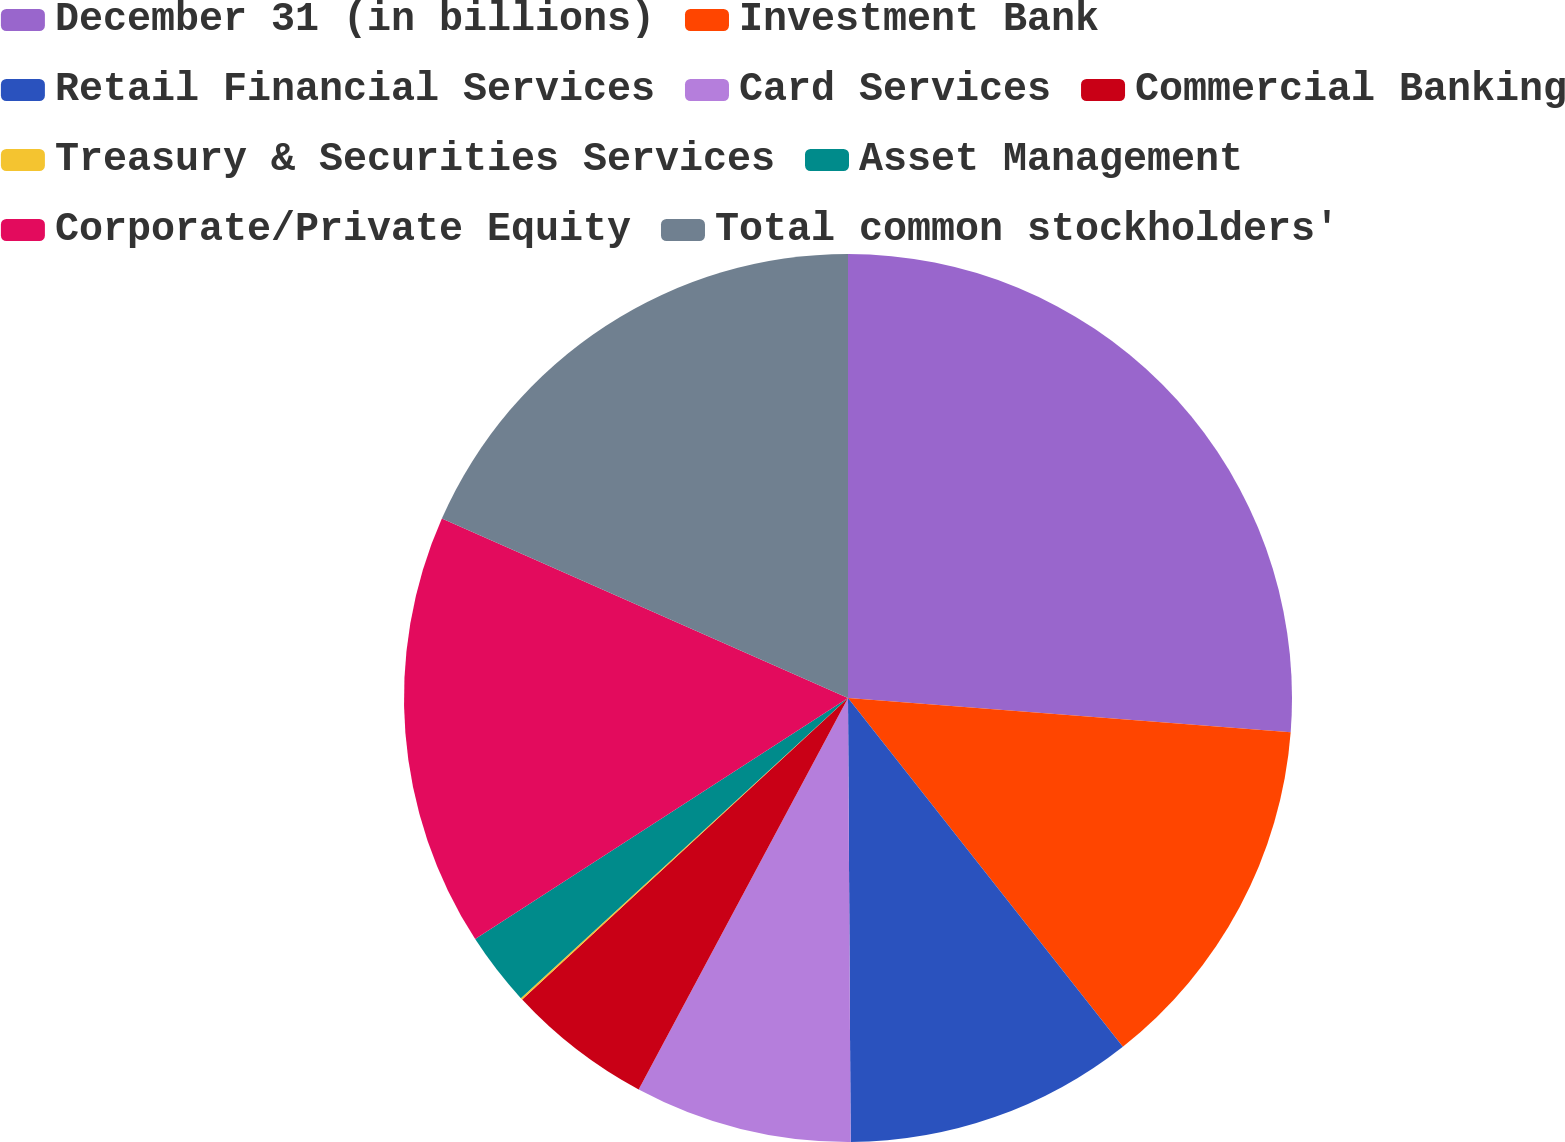Convert chart to OTSL. <chart><loc_0><loc_0><loc_500><loc_500><pie_chart><fcel>December 31 (in billions)<fcel>Investment Bank<fcel>Retail Financial Services<fcel>Card Services<fcel>Commercial Banking<fcel>Treasury & Securities Services<fcel>Asset Management<fcel>Corporate/Private Equity<fcel>Total common stockholders'<nl><fcel>26.23%<fcel>13.15%<fcel>10.53%<fcel>7.91%<fcel>5.3%<fcel>0.07%<fcel>2.68%<fcel>15.76%<fcel>18.38%<nl></chart> 